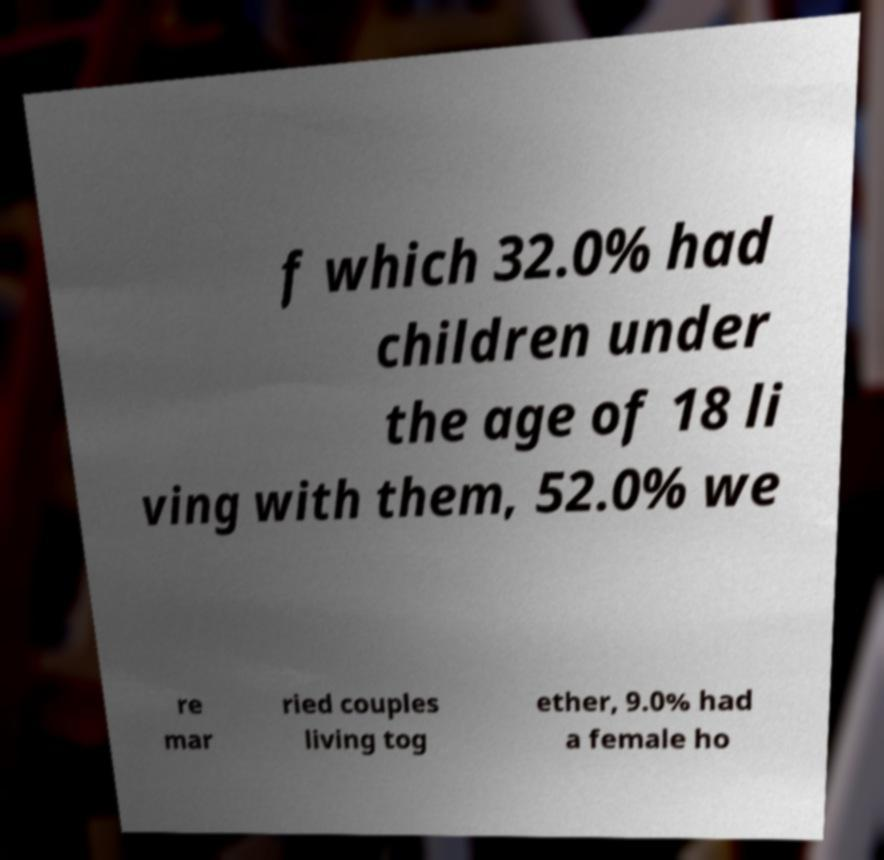Could you assist in decoding the text presented in this image and type it out clearly? f which 32.0% had children under the age of 18 li ving with them, 52.0% we re mar ried couples living tog ether, 9.0% had a female ho 